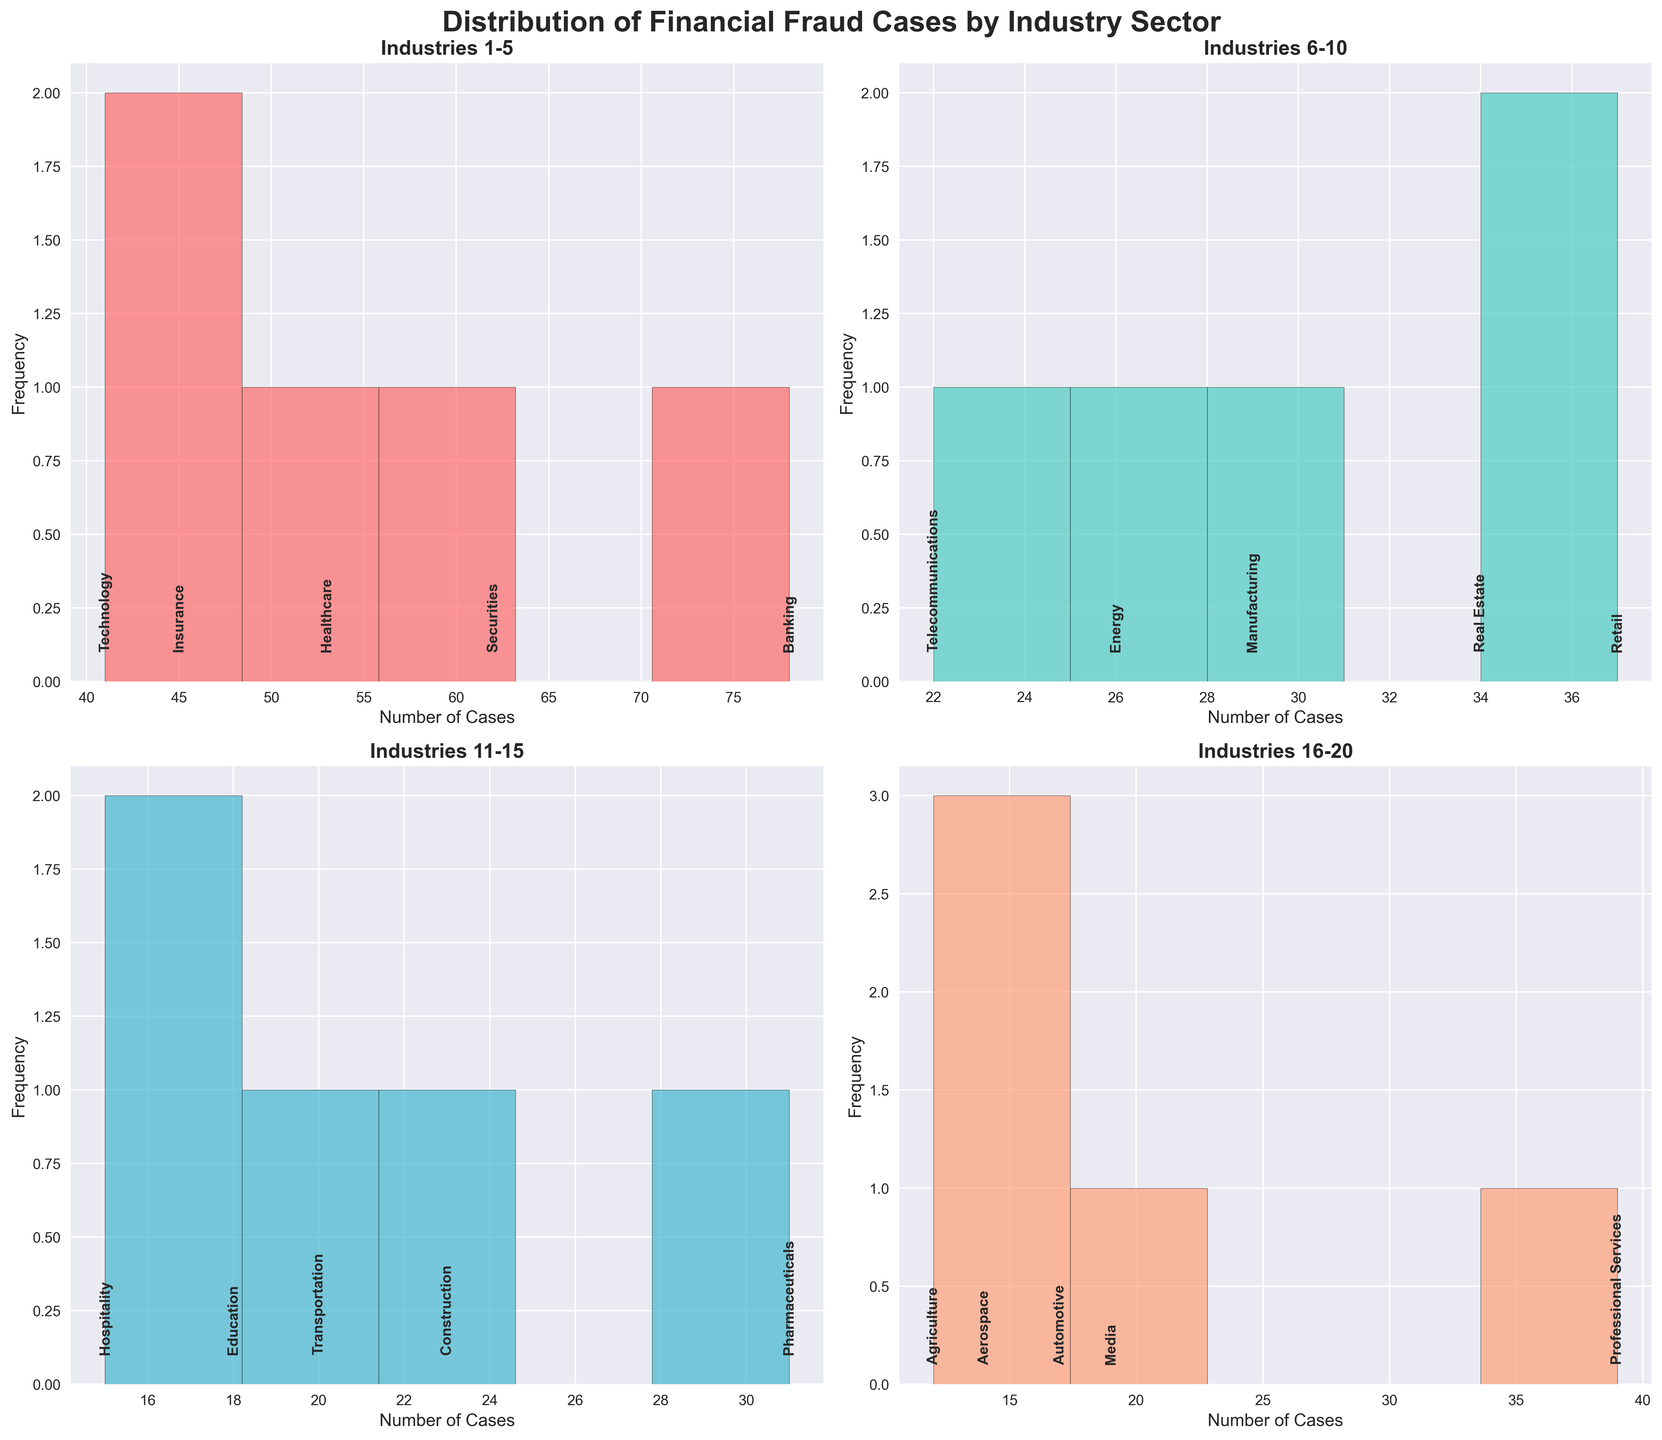What does the title of the figure indicate? The title "Distribution of Financial Fraud Cases by Industry Sector" provides an overview that the figure depicts how fraud cases are distributed across various industry sectors.
Answer: Distribution of Financial Fraud Cases by Industry Sector How many industry sectors are analyzed in each subplot? Each subplot displays data for five different industry sectors, which can be inferred from the repeated layout and labeling.
Answer: Five sectors per subplot Which industry range is covered in the first subplot? The first subplot's title, "Industries 1-5," indicates it covers the first five industries in the dataset. Specifically, it includes Banking, Securities, Insurance, Healthcare, and Technology.
Answer: Banking to Technology What is the approximate range of cases covered in the second subplot? By examining the x-axis of the second subplot titled "Industries 6-10," the range of cases spans from around 20 to 40, based on the frequency of cases in Retail, Manufacturing, Real Estate, Energy, and Telecommunications industries.
Answer: Approximately 20 to 40 cases Which industry has the highest number of cases in the first subplot? Banking has the highest number of cases in the first subplot, as indicated by its position on the x-axis with 78 cases.
Answer: Banking What is the average number of cases for industries in the third subplot? The industries in the third subplot are Education (18), Transportation (20), Hospitality (15), Construction (23), and Pharmaceuticals (31). Adding these, we have 18+20+15+23+31=107. The average is then 107/5.
Answer: 21.4 Compare the number of cases in the Transportation and Professional Services sectors. Which has more cases? Examining the case numbers, Transportation has 20 cases, while Professional Services has 39 cases. Therefore, Professional Services has more cases.
Answer: Professional Services How does the number of cases in the Education industry compare to the Automotive industry? The Education industry has 18 cases, while the Automotive industry has 17. Thus, Education has one more case than Automotive.
Answer: Education Are there more or fewer than 20 cases in the Telecommunications industry? The x-axis label indicates that the Telecommunications sector has 22 cases, which is more than 20.
Answer: More What is a notable trend shown across all subplots? A notable trend is the variation in the number of fraud cases across different industry sectors, with some sectors having significantly higher cases compared to others, such as Banking and Professional Services.
Answer: Variation in number of cases across sectors 